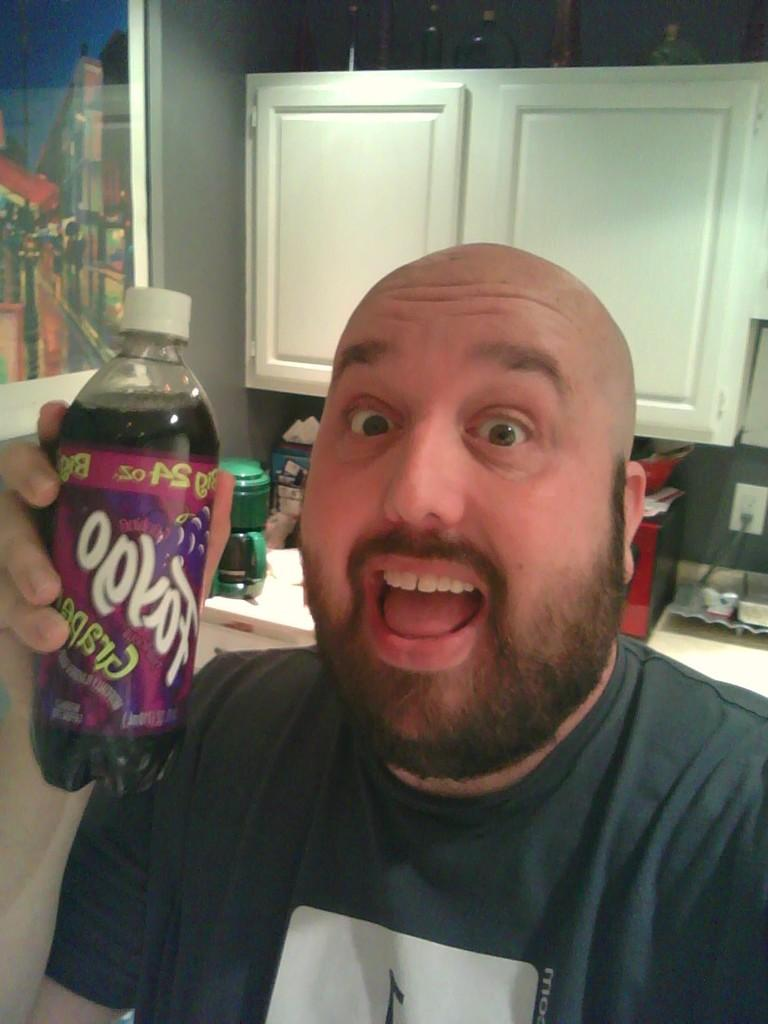Who is present in the image? There is a man in the image. What is the man holding in his hand? The man is holding a bottle in his hand. What type of event is the man attending in the image? There is no indication of an event in the image; it only shows a man holding a bottle. What show is the man watching in the image? There is no show or any indication of a screen or performance in the image. 